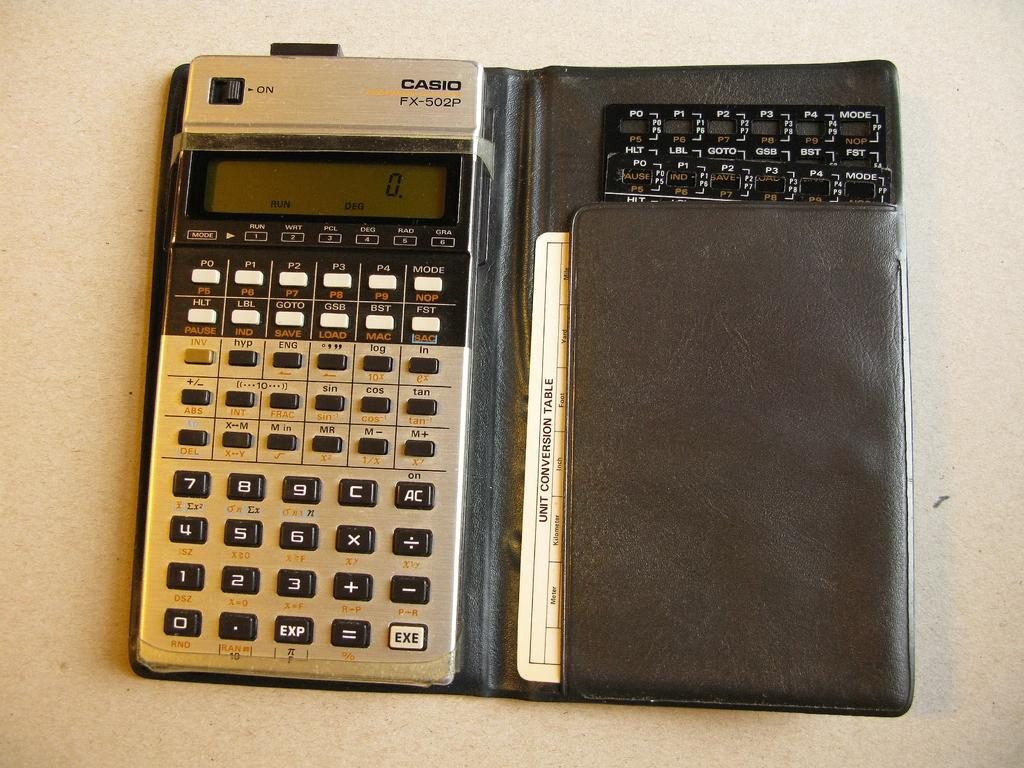<image>
Present a compact description of the photo's key features. A Casio FX-502P calculator sits on a table. 